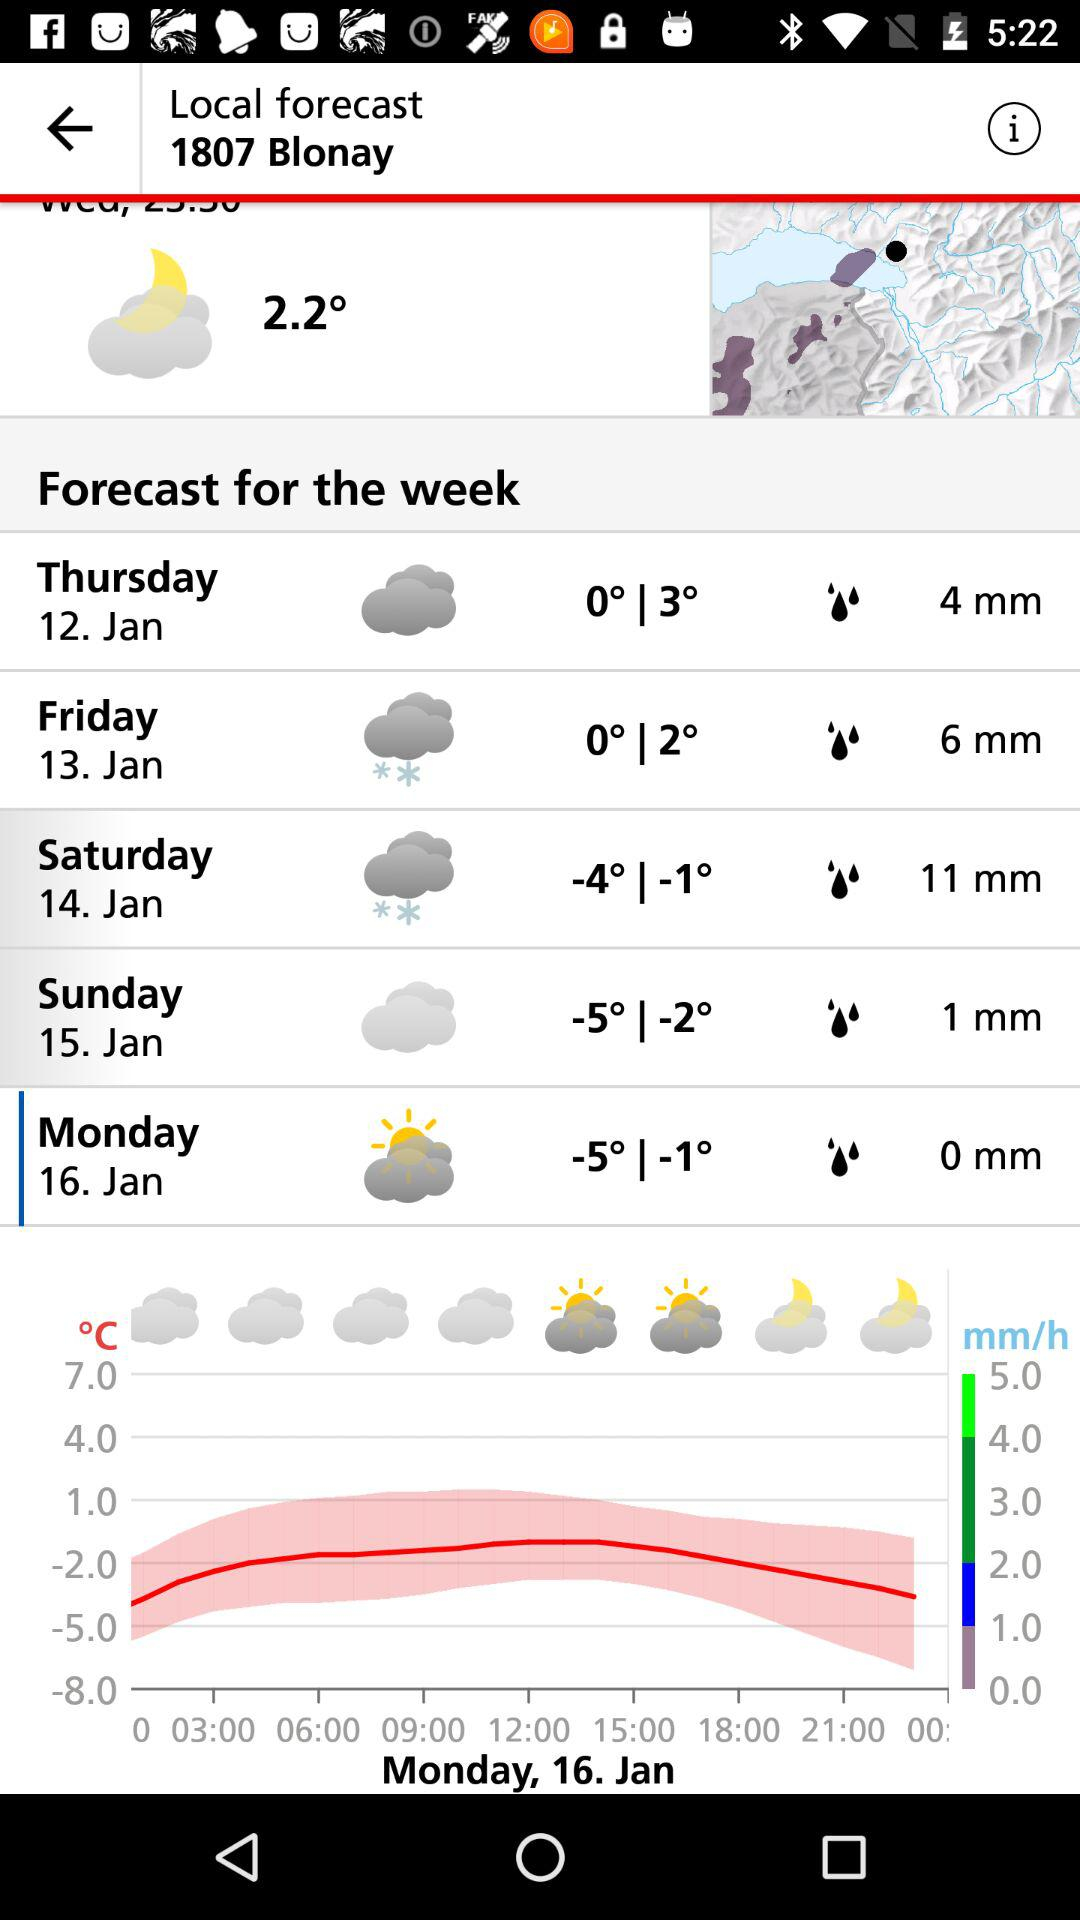What is the temperature on Thursday? The temperature on Thursday is 0° to 3°. 